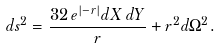<formula> <loc_0><loc_0><loc_500><loc_500>d s ^ { 2 } = { \frac { 3 2 \, e ^ { | - r | } d X \, d Y } { r } } + r ^ { 2 } d \Omega ^ { 2 } .</formula> 